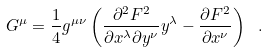<formula> <loc_0><loc_0><loc_500><loc_500>G ^ { \mu } = \frac { 1 } { 4 } g ^ { \mu \nu } \left ( \frac { \partial ^ { 2 } F ^ { 2 } } { \partial x ^ { \lambda } \partial y ^ { \nu } } y ^ { \lambda } - \frac { \partial F ^ { 2 } } { \partial x ^ { \nu } } \right ) \ .</formula> 